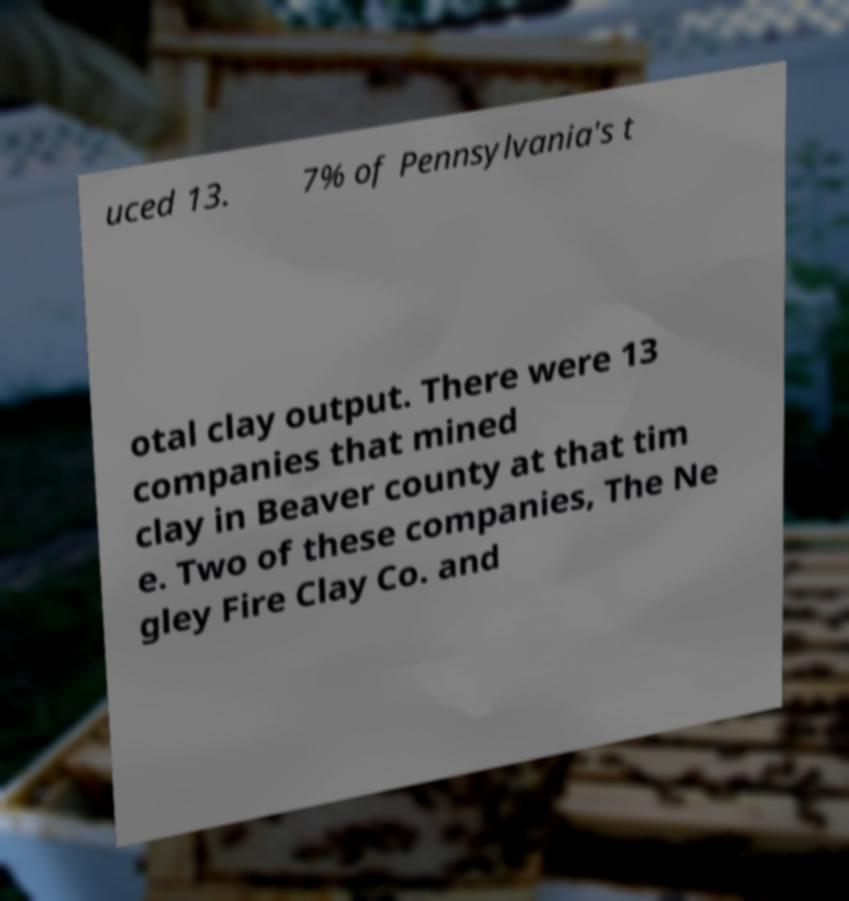Can you accurately transcribe the text from the provided image for me? uced 13. 7% of Pennsylvania's t otal clay output. There were 13 companies that mined clay in Beaver county at that tim e. Two of these companies, The Ne gley Fire Clay Co. and 